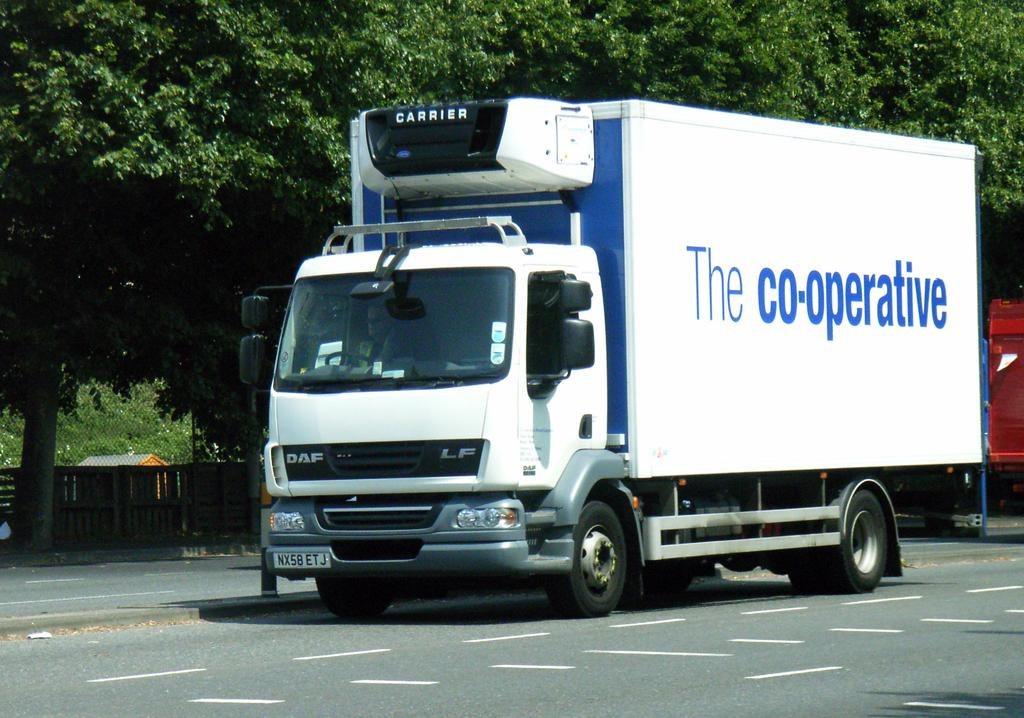What is on the road in the image? There is a vehicle on the road in the image. What type of barrier can be seen in the image? There is a wooden fence in the image. What type of building is visible in the image? There is a house with a roof in the image. What type of vegetation is present in the image? There is a group of trees in the image. Can you tell me how many horses are in the image? There are no horses present in the image. What type of plant is growing near the wooden fence in the image? There is no specific plant mentioned in the provided facts, and the image does not show any plants near the wooden fence. 